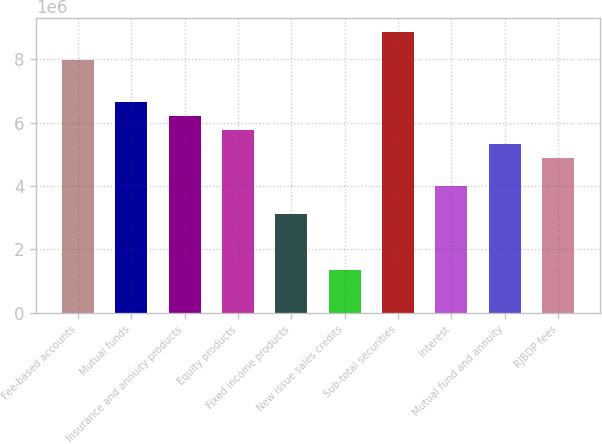<chart> <loc_0><loc_0><loc_500><loc_500><bar_chart><fcel>Fee-based accounts<fcel>Mutual funds<fcel>Insurance and annuity products<fcel>Equity products<fcel>Fixed income products<fcel>New issue sales credits<fcel>Sub-total securities<fcel>Interest<fcel>Mutual fund and annuity<fcel>RJBDP fees<nl><fcel>7.97489e+06<fcel>6.6484e+06<fcel>6.20624e+06<fcel>5.76408e+06<fcel>3.1111e+06<fcel>1.34244e+06<fcel>8.85922e+06<fcel>3.99542e+06<fcel>5.32191e+06<fcel>4.87975e+06<nl></chart> 